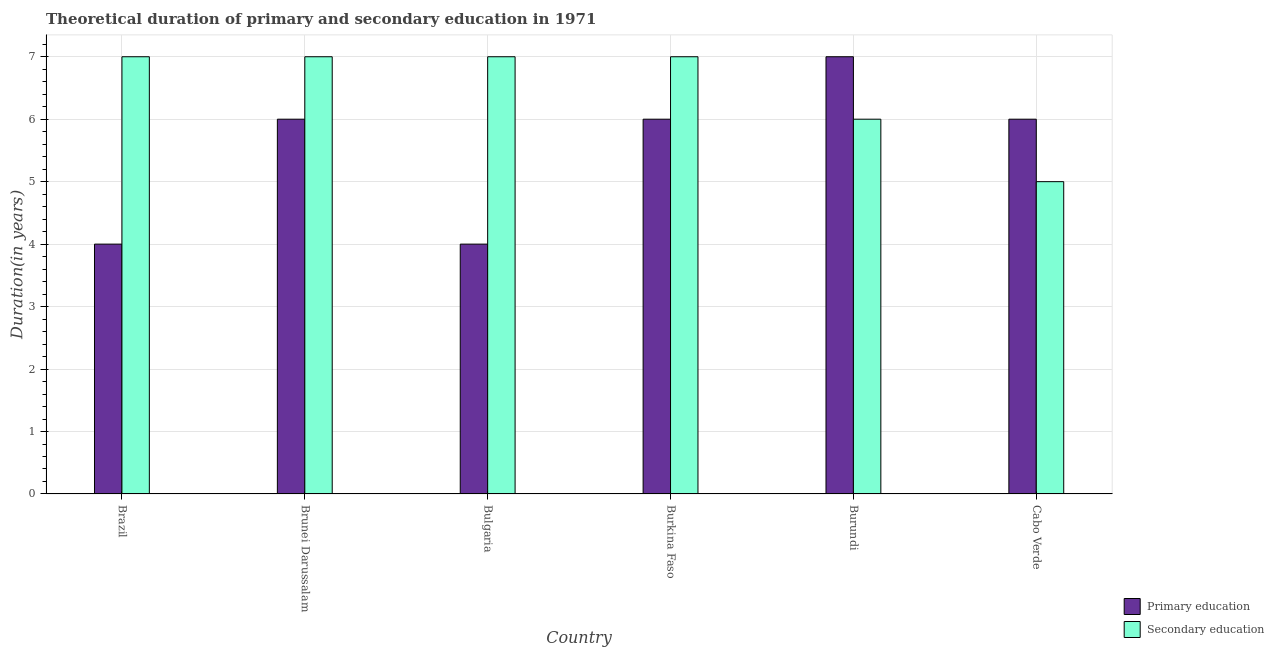How many different coloured bars are there?
Ensure brevity in your answer.  2. Are the number of bars on each tick of the X-axis equal?
Make the answer very short. Yes. How many bars are there on the 2nd tick from the right?
Your response must be concise. 2. What is the label of the 3rd group of bars from the left?
Provide a succinct answer. Bulgaria. In how many cases, is the number of bars for a given country not equal to the number of legend labels?
Offer a terse response. 0. What is the duration of secondary education in Brazil?
Your answer should be compact. 7. Across all countries, what is the maximum duration of secondary education?
Provide a short and direct response. 7. Across all countries, what is the minimum duration of primary education?
Keep it short and to the point. 4. In which country was the duration of primary education minimum?
Give a very brief answer. Brazil. What is the total duration of primary education in the graph?
Provide a succinct answer. 33. What is the difference between the duration of secondary education in Brazil and that in Burundi?
Keep it short and to the point. 1. What is the difference between the duration of secondary education in Brunei Darussalam and the duration of primary education in Cabo Verde?
Your answer should be compact. 1. What is the average duration of secondary education per country?
Offer a terse response. 6.5. What is the difference between the duration of primary education and duration of secondary education in Bulgaria?
Offer a terse response. -3. What is the ratio of the duration of primary education in Brazil to that in Burkina Faso?
Your answer should be compact. 0.67. Is the duration of primary education in Burkina Faso less than that in Cabo Verde?
Make the answer very short. No. What is the difference between the highest and the second highest duration of secondary education?
Provide a succinct answer. 0. What is the difference between the highest and the lowest duration of primary education?
Offer a terse response. 3. Is the sum of the duration of secondary education in Burkina Faso and Cabo Verde greater than the maximum duration of primary education across all countries?
Offer a very short reply. Yes. What does the 2nd bar from the left in Cabo Verde represents?
Keep it short and to the point. Secondary education. What does the 1st bar from the right in Bulgaria represents?
Your answer should be very brief. Secondary education. Where does the legend appear in the graph?
Offer a very short reply. Bottom right. What is the title of the graph?
Your answer should be very brief. Theoretical duration of primary and secondary education in 1971. What is the label or title of the X-axis?
Offer a terse response. Country. What is the label or title of the Y-axis?
Make the answer very short. Duration(in years). What is the Duration(in years) in Secondary education in Burkina Faso?
Your response must be concise. 7. What is the Duration(in years) of Primary education in Burundi?
Your response must be concise. 7. Across all countries, what is the maximum Duration(in years) in Primary education?
Ensure brevity in your answer.  7. Across all countries, what is the minimum Duration(in years) of Primary education?
Provide a succinct answer. 4. Across all countries, what is the minimum Duration(in years) in Secondary education?
Your response must be concise. 5. What is the total Duration(in years) of Secondary education in the graph?
Provide a short and direct response. 39. What is the difference between the Duration(in years) in Primary education in Brazil and that in Bulgaria?
Make the answer very short. 0. What is the difference between the Duration(in years) of Secondary education in Brazil and that in Bulgaria?
Provide a succinct answer. 0. What is the difference between the Duration(in years) of Primary education in Brazil and that in Burundi?
Offer a very short reply. -3. What is the difference between the Duration(in years) in Primary education in Brazil and that in Cabo Verde?
Provide a succinct answer. -2. What is the difference between the Duration(in years) of Primary education in Brunei Darussalam and that in Bulgaria?
Make the answer very short. 2. What is the difference between the Duration(in years) in Primary education in Brunei Darussalam and that in Burundi?
Your answer should be compact. -1. What is the difference between the Duration(in years) in Primary education in Brunei Darussalam and that in Cabo Verde?
Your response must be concise. 0. What is the difference between the Duration(in years) in Secondary education in Brunei Darussalam and that in Cabo Verde?
Provide a short and direct response. 2. What is the difference between the Duration(in years) in Primary education in Burundi and that in Cabo Verde?
Offer a terse response. 1. What is the difference between the Duration(in years) in Secondary education in Burundi and that in Cabo Verde?
Give a very brief answer. 1. What is the difference between the Duration(in years) of Primary education in Brazil and the Duration(in years) of Secondary education in Brunei Darussalam?
Give a very brief answer. -3. What is the difference between the Duration(in years) of Primary education in Brazil and the Duration(in years) of Secondary education in Burkina Faso?
Give a very brief answer. -3. What is the difference between the Duration(in years) of Primary education in Brazil and the Duration(in years) of Secondary education in Burundi?
Your response must be concise. -2. What is the difference between the Duration(in years) in Primary education in Brazil and the Duration(in years) in Secondary education in Cabo Verde?
Keep it short and to the point. -1. What is the difference between the Duration(in years) of Primary education in Brunei Darussalam and the Duration(in years) of Secondary education in Bulgaria?
Provide a succinct answer. -1. What is the difference between the Duration(in years) in Primary education in Brunei Darussalam and the Duration(in years) in Secondary education in Cabo Verde?
Ensure brevity in your answer.  1. What is the difference between the Duration(in years) in Primary education in Burkina Faso and the Duration(in years) in Secondary education in Burundi?
Your answer should be very brief. 0. What is the difference between the Duration(in years) of Primary education in Burkina Faso and the Duration(in years) of Secondary education in Cabo Verde?
Your response must be concise. 1. What is the difference between the Duration(in years) in Primary education in Burundi and the Duration(in years) in Secondary education in Cabo Verde?
Ensure brevity in your answer.  2. What is the average Duration(in years) in Primary education per country?
Your answer should be compact. 5.5. What is the average Duration(in years) of Secondary education per country?
Offer a very short reply. 6.5. What is the difference between the Duration(in years) in Primary education and Duration(in years) in Secondary education in Burkina Faso?
Give a very brief answer. -1. What is the difference between the Duration(in years) of Primary education and Duration(in years) of Secondary education in Burundi?
Give a very brief answer. 1. What is the ratio of the Duration(in years) in Primary education in Brazil to that in Brunei Darussalam?
Offer a very short reply. 0.67. What is the ratio of the Duration(in years) of Secondary education in Brazil to that in Brunei Darussalam?
Your answer should be very brief. 1. What is the ratio of the Duration(in years) in Primary education in Brazil to that in Bulgaria?
Make the answer very short. 1. What is the ratio of the Duration(in years) in Secondary education in Brazil to that in Bulgaria?
Offer a very short reply. 1. What is the ratio of the Duration(in years) in Secondary education in Brazil to that in Burundi?
Provide a short and direct response. 1.17. What is the ratio of the Duration(in years) in Secondary education in Brazil to that in Cabo Verde?
Make the answer very short. 1.4. What is the ratio of the Duration(in years) of Primary education in Brunei Darussalam to that in Bulgaria?
Your answer should be compact. 1.5. What is the ratio of the Duration(in years) in Primary education in Brunei Darussalam to that in Burkina Faso?
Offer a very short reply. 1. What is the ratio of the Duration(in years) in Secondary education in Brunei Darussalam to that in Burkina Faso?
Provide a succinct answer. 1. What is the ratio of the Duration(in years) in Primary education in Brunei Darussalam to that in Burundi?
Make the answer very short. 0.86. What is the ratio of the Duration(in years) in Secondary education in Brunei Darussalam to that in Burundi?
Provide a succinct answer. 1.17. What is the ratio of the Duration(in years) in Primary education in Brunei Darussalam to that in Cabo Verde?
Offer a very short reply. 1. What is the ratio of the Duration(in years) of Primary education in Bulgaria to that in Burundi?
Ensure brevity in your answer.  0.57. What is the ratio of the Duration(in years) of Primary education in Bulgaria to that in Cabo Verde?
Give a very brief answer. 0.67. What is the ratio of the Duration(in years) in Secondary education in Burkina Faso to that in Burundi?
Offer a terse response. 1.17. What is the ratio of the Duration(in years) in Primary education in Burkina Faso to that in Cabo Verde?
Ensure brevity in your answer.  1. What is the ratio of the Duration(in years) of Secondary education in Burkina Faso to that in Cabo Verde?
Make the answer very short. 1.4. What is the ratio of the Duration(in years) of Primary education in Burundi to that in Cabo Verde?
Provide a succinct answer. 1.17. What is the difference between the highest and the second highest Duration(in years) of Primary education?
Give a very brief answer. 1. What is the difference between the highest and the second highest Duration(in years) of Secondary education?
Your answer should be compact. 0. What is the difference between the highest and the lowest Duration(in years) of Secondary education?
Keep it short and to the point. 2. 